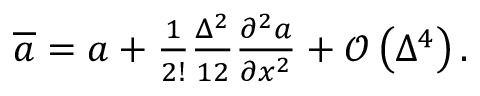<formula> <loc_0><loc_0><loc_500><loc_500>\begin{array} { r } { \overline { a } = a + \frac { 1 } { 2 ! } \frac { \Delta ^ { 2 } } { 1 2 } \frac { \partial ^ { 2 } a } { \partial x ^ { 2 } } + \mathcal { O } \left ( \Delta ^ { 4 } \right ) . } \end{array}</formula> 